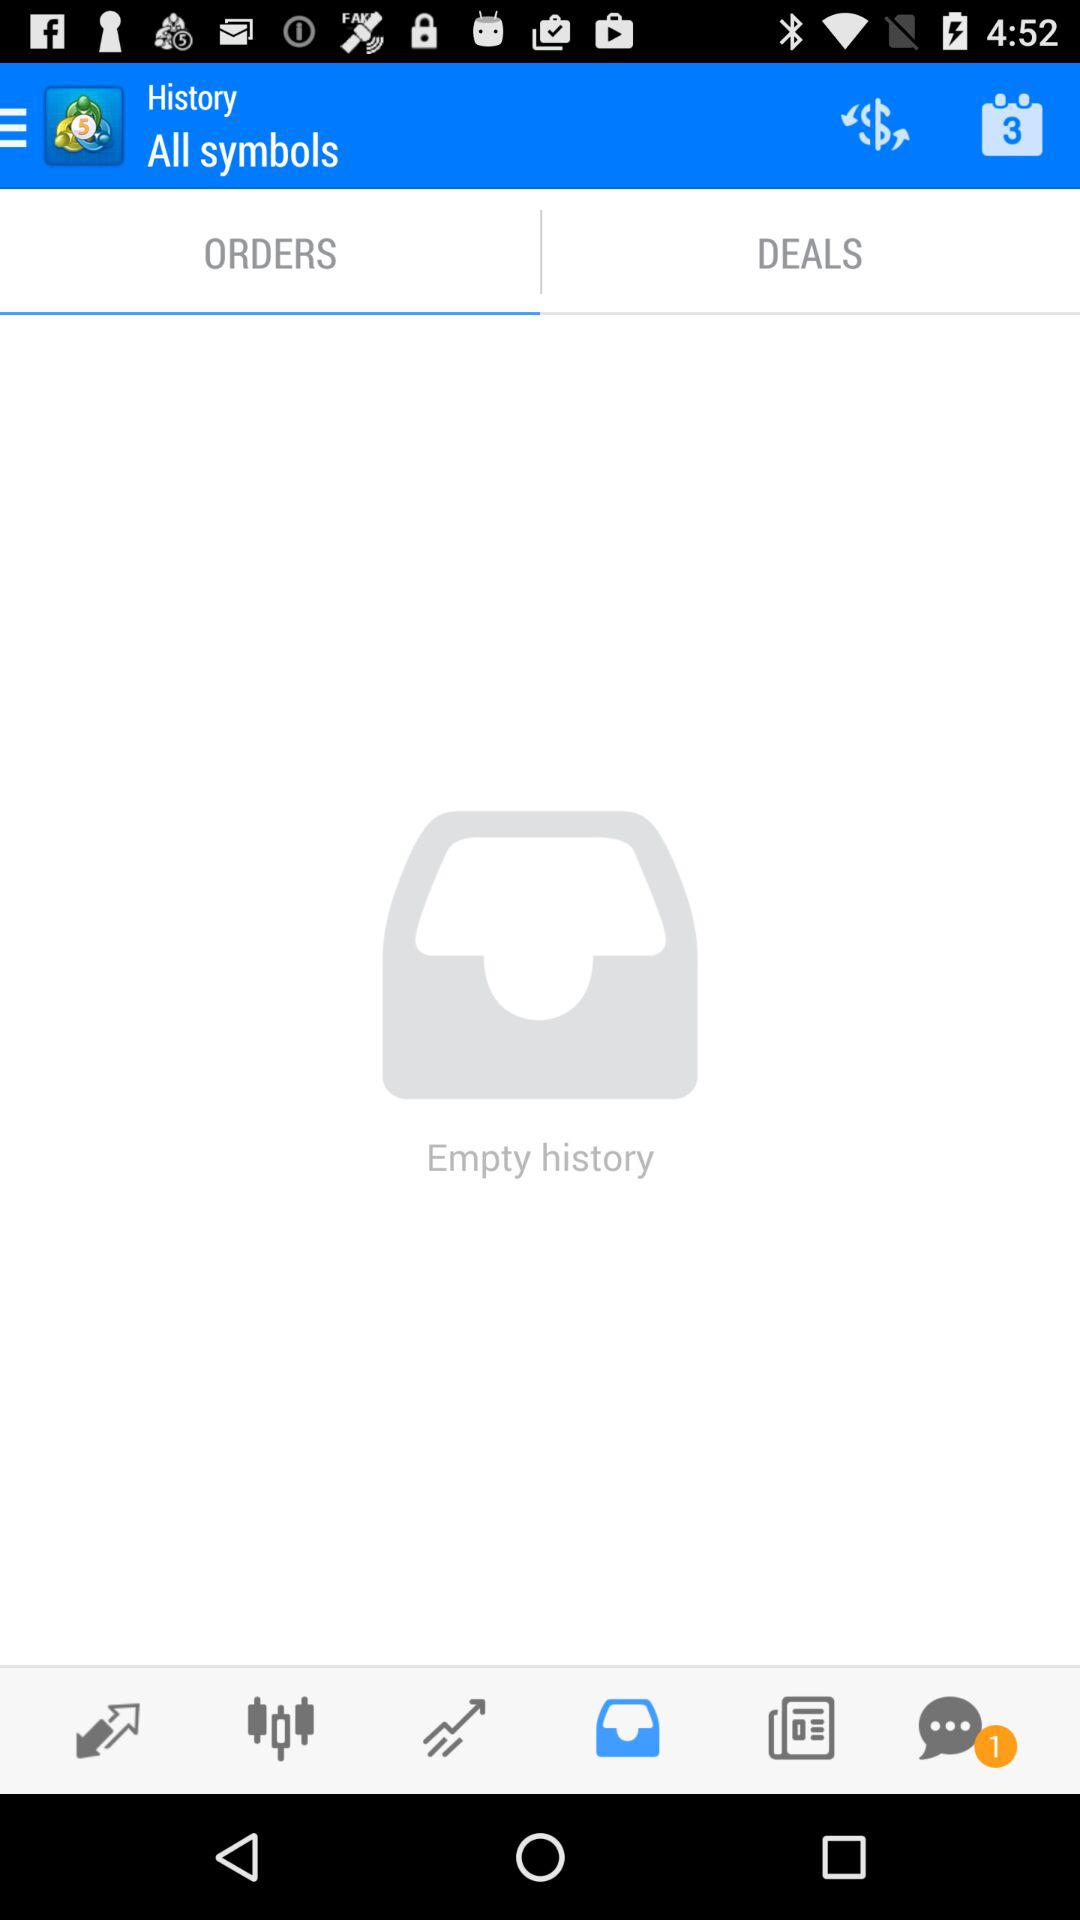What tab is selected? The selected tab is "ORDERS". 